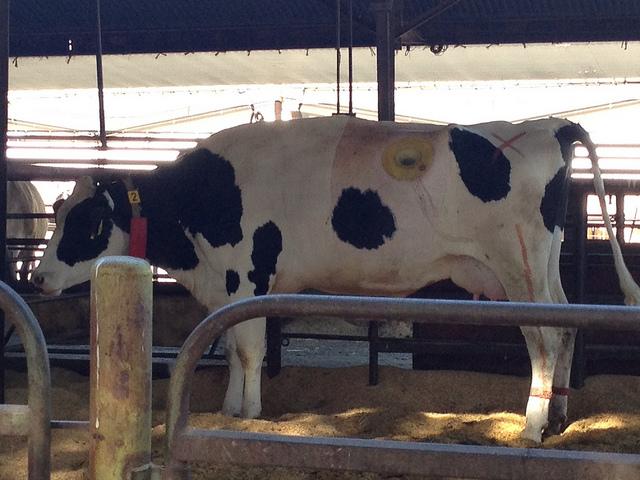What number is around the cow's neck?
Be succinct. 2. Is this cow okay?
Be succinct. No. What is in background of cow?
Short answer required. Fence. 